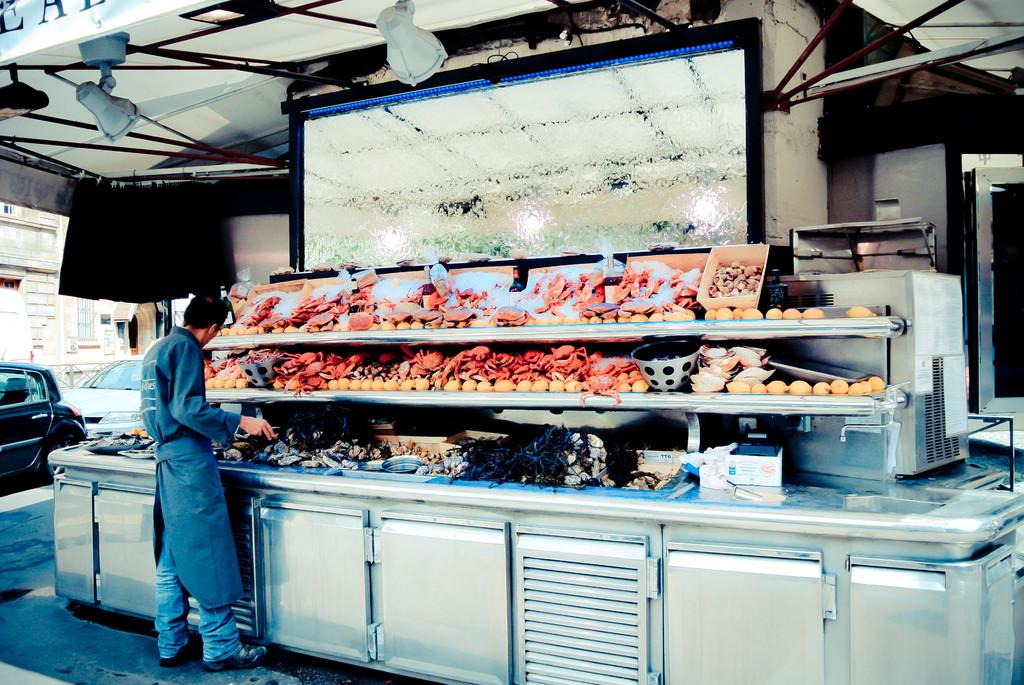What is the man in the image doing? The man is standing on the floor in the image. What can be seen on the screen in the image? The facts do not specify what is on the screen, so we cannot answer this question definitively. What is the rack used for in the image? The purpose of the rack in the image is not specified, so we cannot answer this question definitively. What type of food is visible in the image? The facts do not specify the type of food in the image, so we cannot answer this question definitively. What are the cars in the image doing? The facts do not specify the actions of the cars in the image, so we cannot answer this question definitively. What type of building is visible in the image? The facts do not specify the type of building in the image, so we cannot answer this question definitively. What is the purpose of the lights in the image? The purpose of the lights in the image is not specified, so we cannot answer this question definitively. What type of plate can be seen on the man's sweater in the image? There is no plate visible on the man's sweater in the image, and the man is not wearing a sweater in the image. 